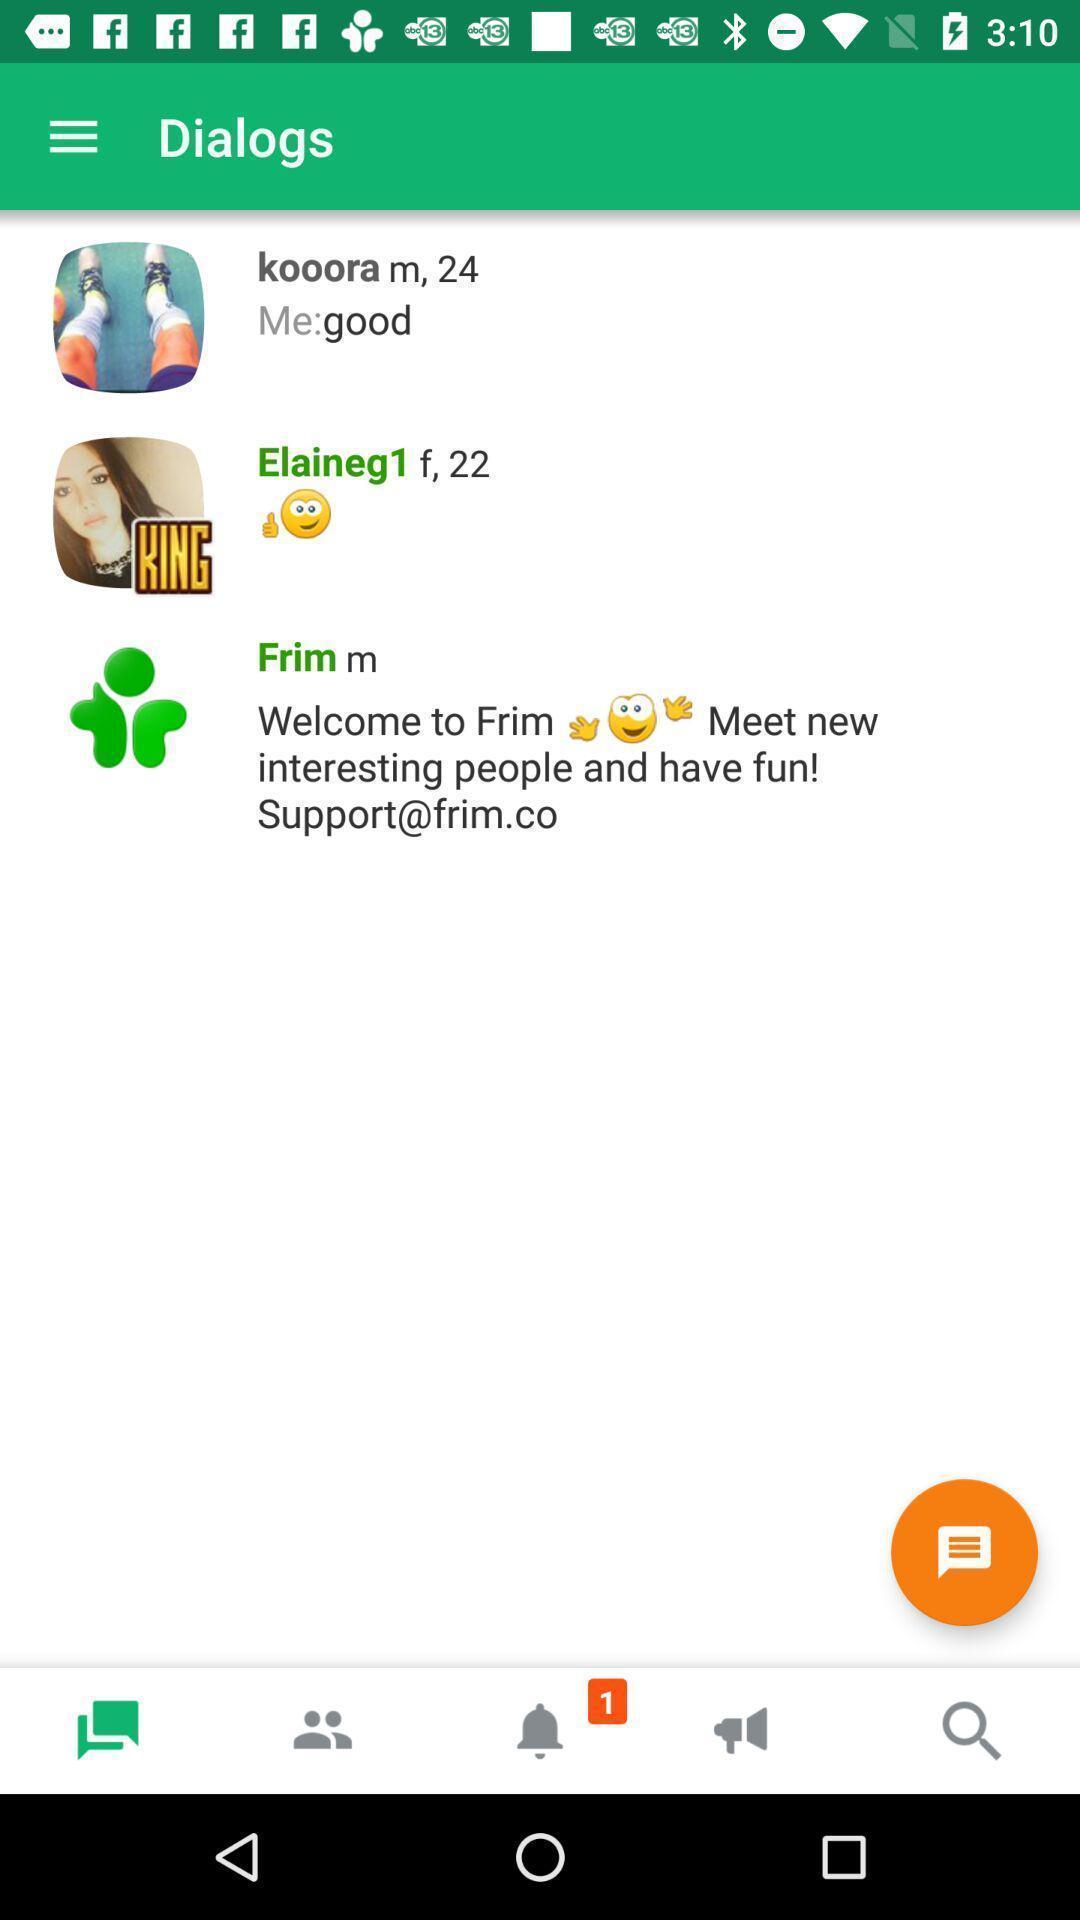Summarize the information in this screenshot. Page displaying various chats. 